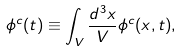<formula> <loc_0><loc_0><loc_500><loc_500>\phi ^ { c } ( t ) \equiv \int _ { V } \frac { d ^ { 3 } { x } } { V } \phi ^ { c } ( { x } , t ) ,</formula> 